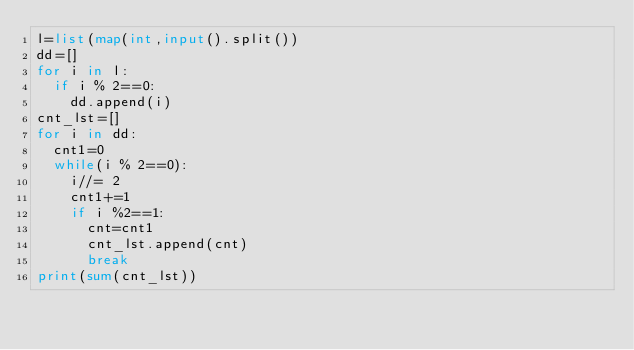Convert code to text. <code><loc_0><loc_0><loc_500><loc_500><_Python_>l=list(map(int,input().split()) 
dd=[]                                                                  
for i in l: 
	if i % 2==0: 
		dd.append(i)       
cnt_lst=[]                                                             
for i in dd: 
	cnt1=0 
	while(i % 2==0): 
		i//= 2 
		cnt1+=1 
		if i %2==1: 
			cnt=cnt1 
			cnt_lst.append(cnt)             
			break 
print(sum(cnt_lst)) </code> 